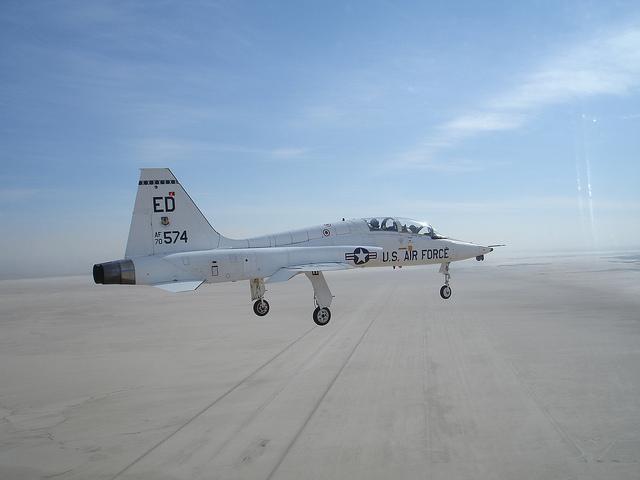Is this a commercial aircraft?
Quick response, please. No. How many people are on the plane?
Give a very brief answer. 2. Are there mountains in the background?
Give a very brief answer. No. What is that tail off?
Short answer required. Plane. Is it cloudy?
Short answer required. No. Is this plane parked at an airport?
Give a very brief answer. No. Is this a passenger plane?
Answer briefly. No. Is this an army plane?
Answer briefly. No. How many planes can be seen?
Answer briefly. 1. How many planes are there?
Be succinct. 1. What is suspended here?
Give a very brief answer. Airplane. What is under the landing gear?
Short answer required. Ground. Approximately what time of day was the picture taken?
Give a very brief answer. Noon. Is the plane taking off or landing?
Write a very short answer. Landing. How many wheels are visible?
Be succinct. 3. Is the door of the plane open?
Concise answer only. No. What military branch is written on the jet?
Short answer required. Air force. Are there people on the steps to the plane?
Write a very short answer. No. Is the plane parked in the runway?
Keep it brief. No. Is the plane being loaded?
Answer briefly. No. How many people can fit in this plane?
Quick response, please. 2. What is this vehicle on?
Give a very brief answer. Air. Where are the planes?
Give a very brief answer. In air. Is this a cargo or passenger plane?
Write a very short answer. Neither. Where is this plane?
Short answer required. Air. What is this person riding?
Concise answer only. Plane. What kind of plane is this?
Give a very brief answer. Jet. What color is the sky?
Give a very brief answer. Blue. What kind of aircraft is this?
Quick response, please. Jet. Is this a jet?
Be succinct. Yes. Is the plane in motion?
Be succinct. Yes. What is the number at the bottom of the photo?
Concise answer only. 574. What are the weather conditions in the photo?
Be succinct. Clear. Where was this picture taken at?
Short answer required. Air. Is it morning, afternoon or evening?
Short answer required. Afternoon. What are the letters on the plane?
Answer briefly. Ed. Is the airplane in the air or on the ground?
Short answer required. Air. What is this plane doing?
Short answer required. Flying. Is the plane on the ground?
Quick response, please. No. Where is the plane located?
Write a very short answer. Sky. What number do you see on the plane?
Quick response, please. 574. 